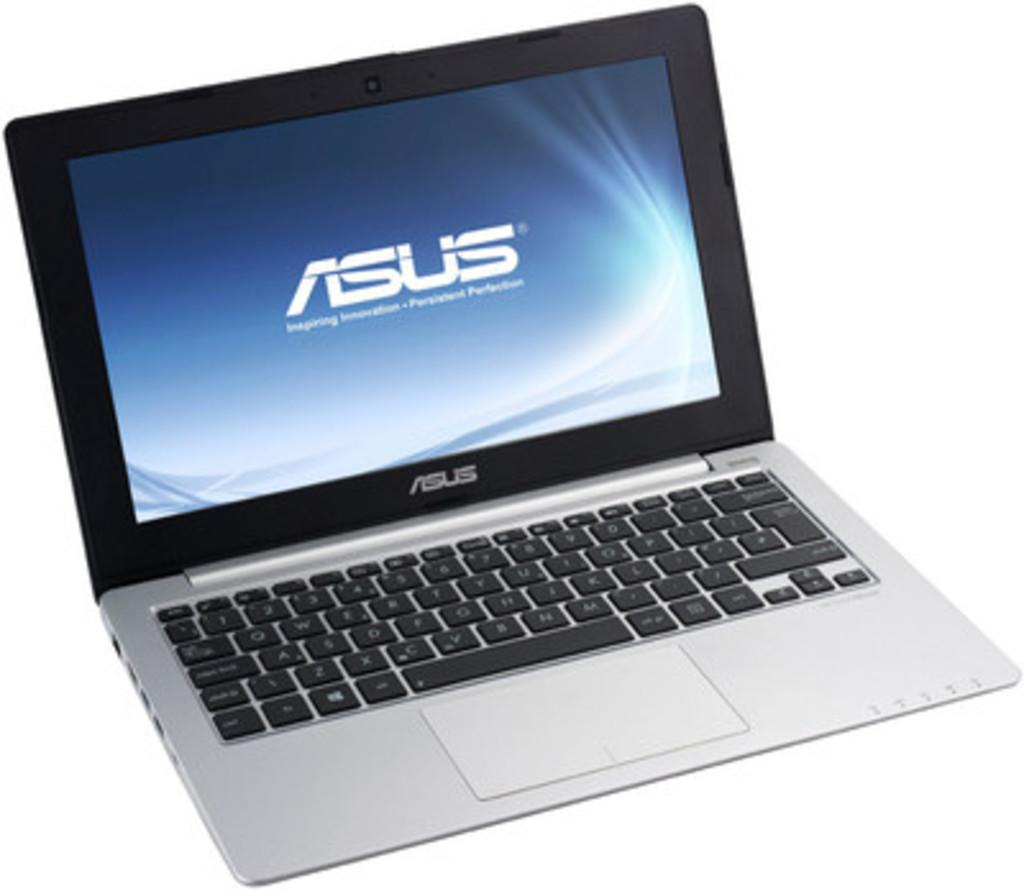<image>
Summarize the visual content of the image. an ASUS laptop is open and turned on 